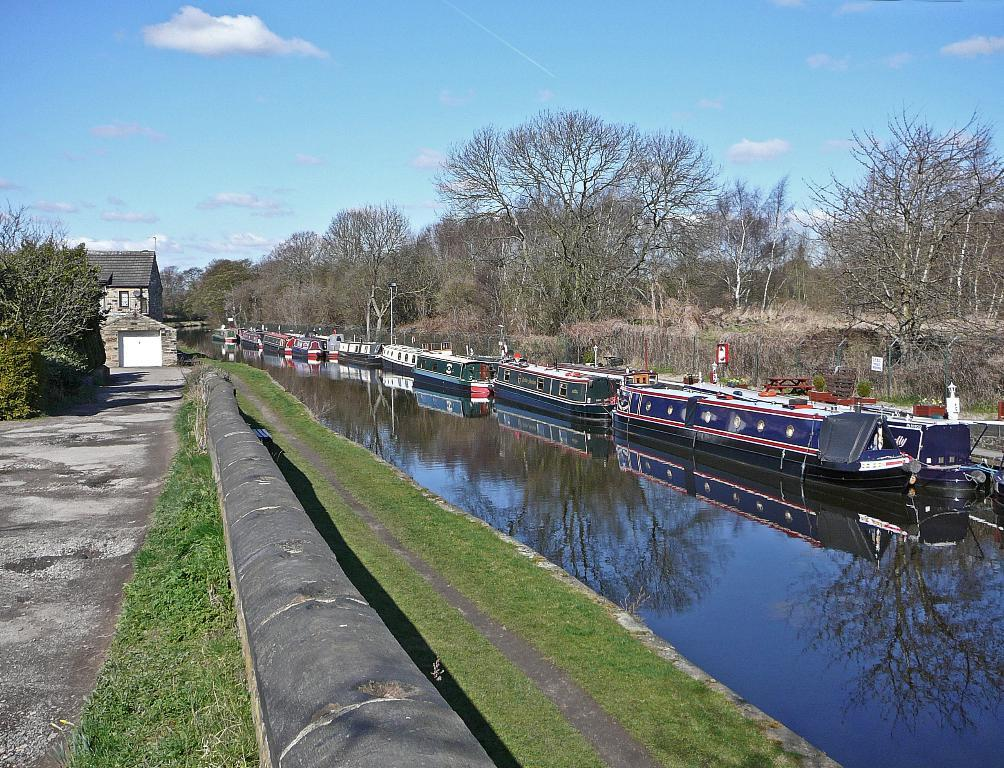What is on the water in the image? There are boats on the water in the image. What type of vegetation can be seen in the image? There are trees and grass in the image. What type of structure is present in the image? There is a building in the image. What is visible in the background of the image? The sky is visible in the background of the image, and there are clouds in the sky. Where is the light patch located in the image? There is no light patch present in the image. What type of mine is visible in the image? There is no mine present in the image. 